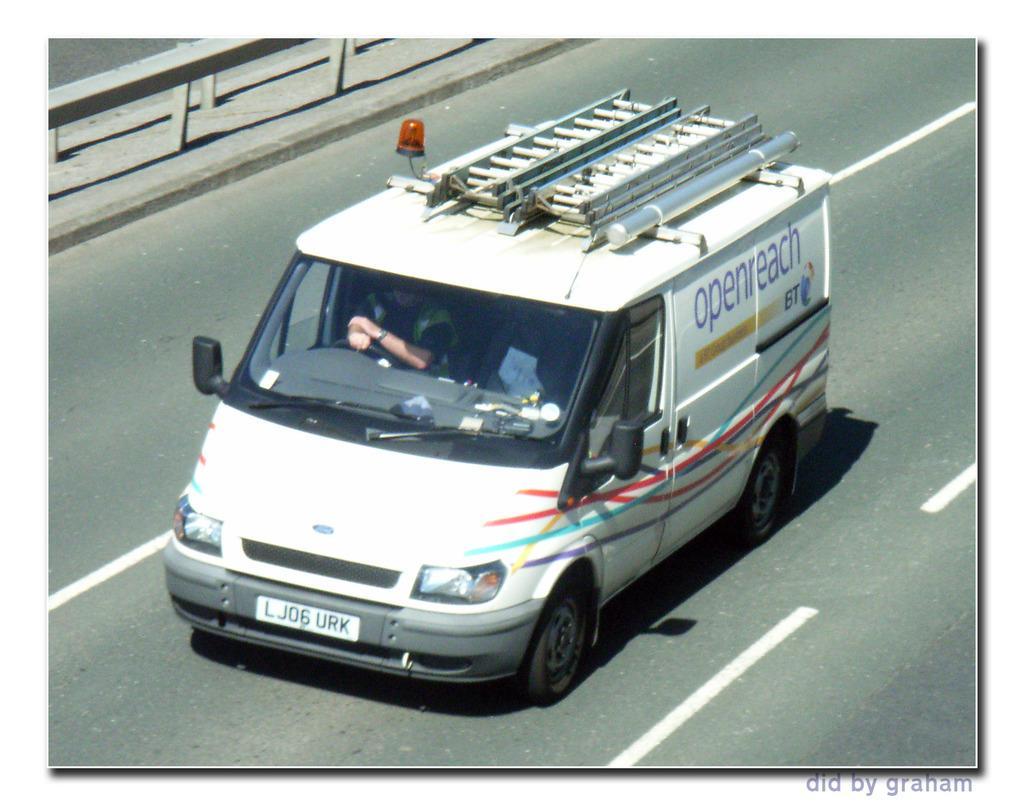Can you describe this image briefly? In the image there is a vehicle on the road and inside the vehicle there is a person sitting in front of the steering. 